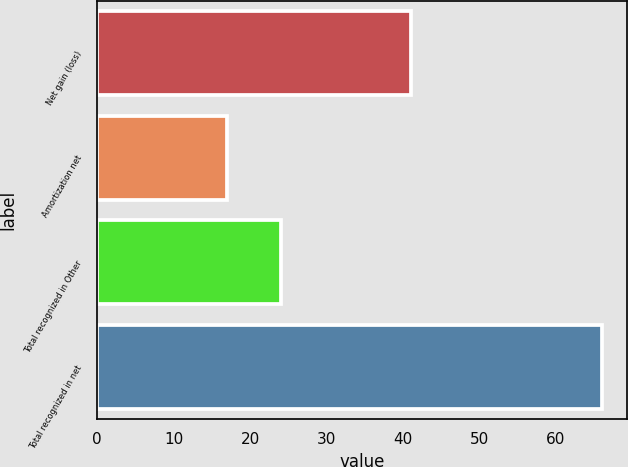Convert chart to OTSL. <chart><loc_0><loc_0><loc_500><loc_500><bar_chart><fcel>Net gain (loss)<fcel>Amortization net<fcel>Total recognized in Other<fcel>Total recognized in net<nl><fcel>41<fcel>17<fcel>24<fcel>66<nl></chart> 